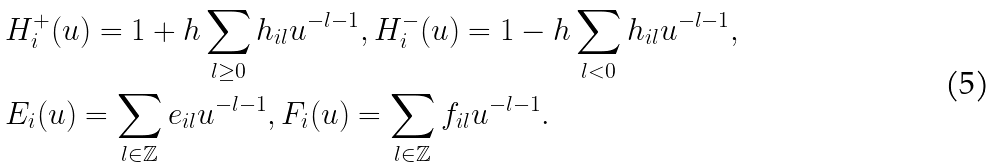<formula> <loc_0><loc_0><loc_500><loc_500>& H ^ { + } _ { i } ( u ) = 1 + h \sum _ { l \geq 0 } h _ { i l } u ^ { - l - 1 } , H ^ { - } _ { i } ( u ) = 1 - h \sum _ { l < 0 } h _ { i l } u ^ { - l - 1 } , \\ & E _ { i } ( u ) = \sum _ { l \in \mathbb { Z } } e _ { i l } u ^ { - l - 1 } , F _ { i } ( u ) = \sum _ { l \in \mathbb { Z } } f _ { i l } u ^ { - l - 1 } .</formula> 